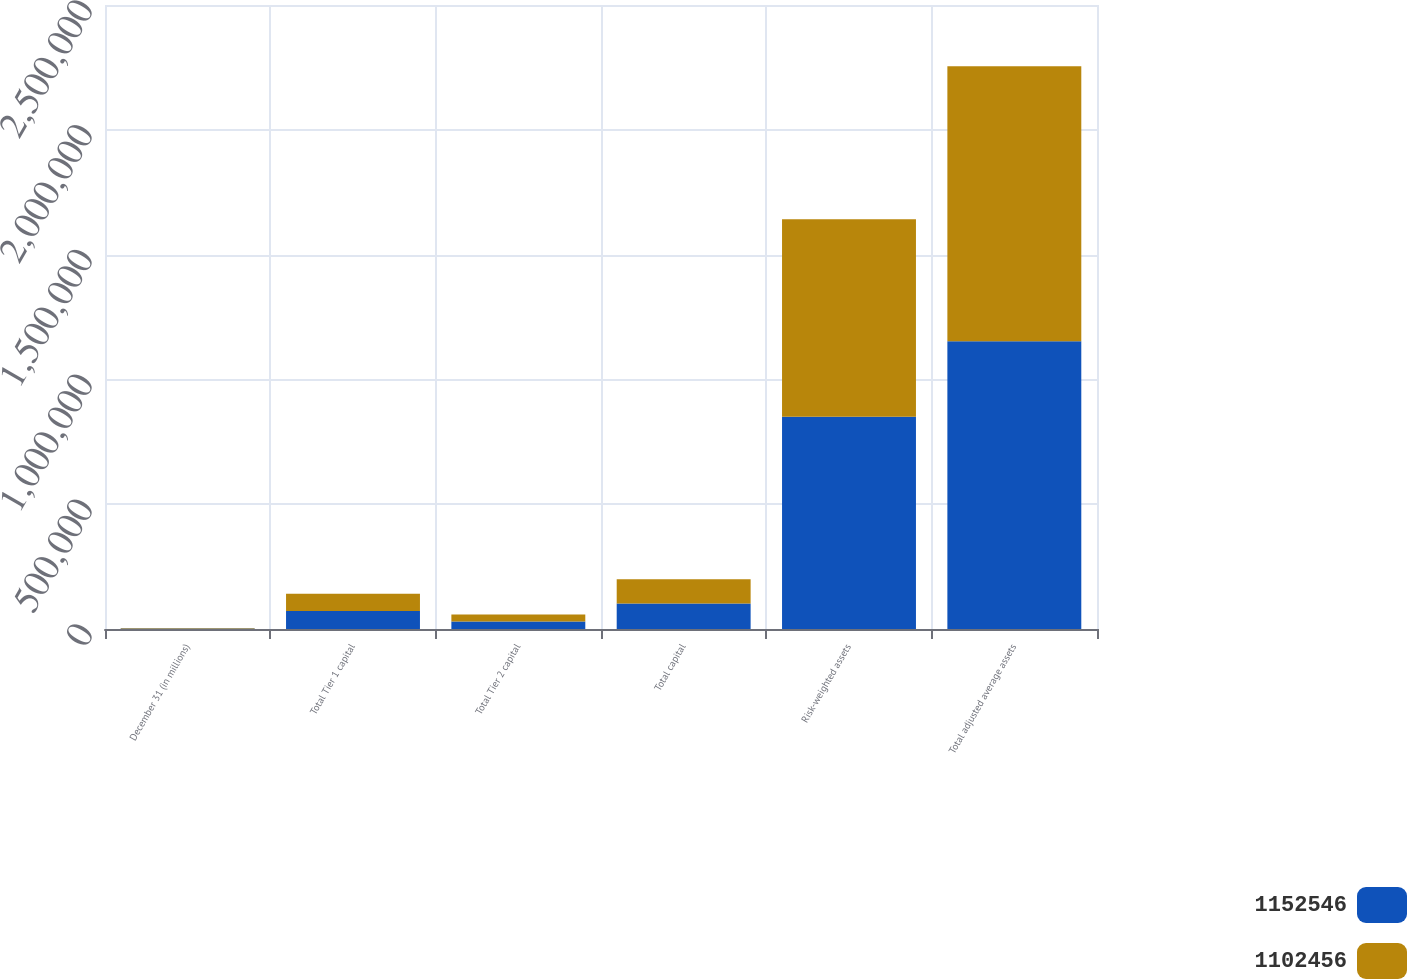Convert chart. <chart><loc_0><loc_0><loc_500><loc_500><stacked_bar_chart><ecel><fcel>December 31 (in millions)<fcel>Total Tier 1 capital<fcel>Total Tier 2 capital<fcel>Total capital<fcel>Risk-weighted assets<fcel>Total adjusted average assets<nl><fcel>1.15255e+06<fcel>2005<fcel>72474<fcel>29963<fcel>102437<fcel>850643<fcel>1.15255e+06<nl><fcel>1.10246e+06<fcel>2004<fcel>68621<fcel>28186<fcel>96807<fcel>791373<fcel>1.10246e+06<nl></chart> 